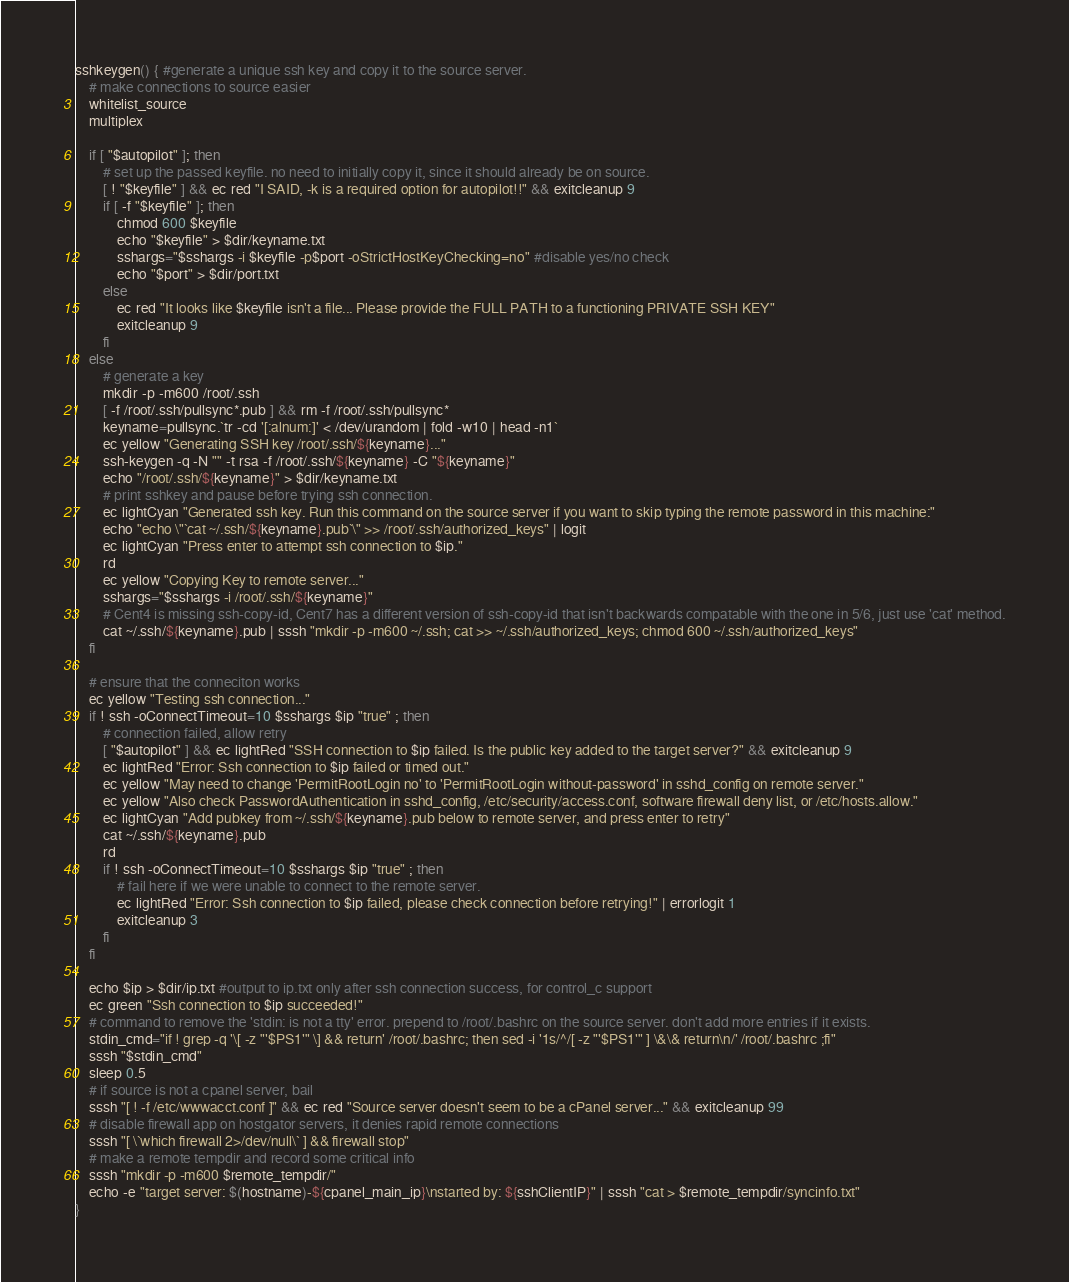<code> <loc_0><loc_0><loc_500><loc_500><_Bash_>sshkeygen() { #generate a unique ssh key and copy it to the source server.
	# make connections to source easier
	whitelist_source
	multiplex

	if [ "$autopilot" ]; then
		# set up the passed keyfile. no need to initially copy it, since it should already be on source.
		[ ! "$keyfile" ] && ec red "I SAID, -k is a required option for autopilot!!" && exitcleanup 9
		if [ -f "$keyfile" ]; then
			chmod 600 $keyfile
			echo "$keyfile" > $dir/keyname.txt
			sshargs="$sshargs -i $keyfile -p$port -oStrictHostKeyChecking=no" #disable yes/no check
			echo "$port" > $dir/port.txt
		else
			ec red "It looks like $keyfile isn't a file... Please provide the FULL PATH to a functioning PRIVATE SSH KEY"
			exitcleanup 9
		fi
	else
		# generate a key
		mkdir -p -m600 /root/.ssh
		[ -f /root/.ssh/pullsync*.pub ] && rm -f /root/.ssh/pullsync*
		keyname=pullsync.`tr -cd '[:alnum:]' < /dev/urandom | fold -w10 | head -n1`
		ec yellow "Generating SSH key /root/.ssh/${keyname}..."
		ssh-keygen -q -N "" -t rsa -f /root/.ssh/${keyname} -C "${keyname}"
		echo "/root/.ssh/${keyname}" > $dir/keyname.txt
		# print sshkey and pause before trying ssh connection.
		ec lightCyan "Generated ssh key. Run this command on the source server if you want to skip typing the remote password in this machine:"
		echo "echo \"`cat ~/.ssh/${keyname}.pub`\" >> /root/.ssh/authorized_keys" | logit
		ec lightCyan "Press enter to attempt ssh connection to $ip."
		rd
		ec yellow "Copying Key to remote server..."
		sshargs="$sshargs -i /root/.ssh/${keyname}"
		# Cent4 is missing ssh-copy-id, Cent7 has a different version of ssh-copy-id that isn't backwards compatable with the one in 5/6, just use 'cat' method.
		cat ~/.ssh/${keyname}.pub | sssh "mkdir -p -m600 ~/.ssh; cat >> ~/.ssh/authorized_keys; chmod 600 ~/.ssh/authorized_keys"
	fi

	# ensure that the conneciton works
	ec yellow "Testing ssh connection..."
	if ! ssh -oConnectTimeout=10 $sshargs $ip "true" ; then
		# connection failed, allow retry
		[ "$autopilot" ] && ec lightRed "SSH connection to $ip failed. Is the public key added to the target server?" && exitcleanup 9
		ec lightRed "Error: Ssh connection to $ip failed or timed out."
		ec yellow "May need to change 'PermitRootLogin no' to 'PermitRootLogin without-password' in sshd_config on remote server."
		ec yellow "Also check PasswordAuthentication in sshd_config, /etc/security/access.conf, software firewall deny list, or /etc/hosts.allow."
		ec lightCyan "Add pubkey from ~/.ssh/${keyname}.pub below to remote server, and press enter to retry"
		cat ~/.ssh/${keyname}.pub
		rd
		if ! ssh -oConnectTimeout=10 $sshargs $ip "true" ; then
			# fail here if we were unable to connect to the remote server.
			ec lightRed "Error: Ssh connection to $ip failed, please check connection before retrying!" | errorlogit 1
			exitcleanup 3
		fi
	fi

	echo $ip > $dir/ip.txt #output to ip.txt only after ssh connection success, for control_c support
	ec green "Ssh connection to $ip succeeded!"
	# command to remove the 'stdin: is not a tty' error. prepend to /root/.bashrc on the source server. don't add more entries if it exists.
	stdin_cmd="if ! grep -q '\[ -z "'$PS1'" \] && return' /root/.bashrc; then sed -i '1s/^/[ -z "'$PS1'" ] \&\& return\n/' /root/.bashrc ;fi"
	sssh "$stdin_cmd"
	sleep 0.5
	# if source is not a cpanel server, bail
	sssh "[ ! -f /etc/wwwacct.conf ]" && ec red "Source server doesn't seem to be a cPanel server..." && exitcleanup 99
	# disable firewall app on hostgator servers, it denies rapid remote connections
	sssh "[ \`which firewall 2>/dev/null\` ] && firewall stop"
	# make a remote tempdir and record some critical info
	sssh "mkdir -p -m600 $remote_tempdir/"
	echo -e "target server: $(hostname)-${cpanel_main_ip}\nstarted by: ${sshClientIP}" | sssh "cat > $remote_tempdir/syncinfo.txt"
}
</code> 